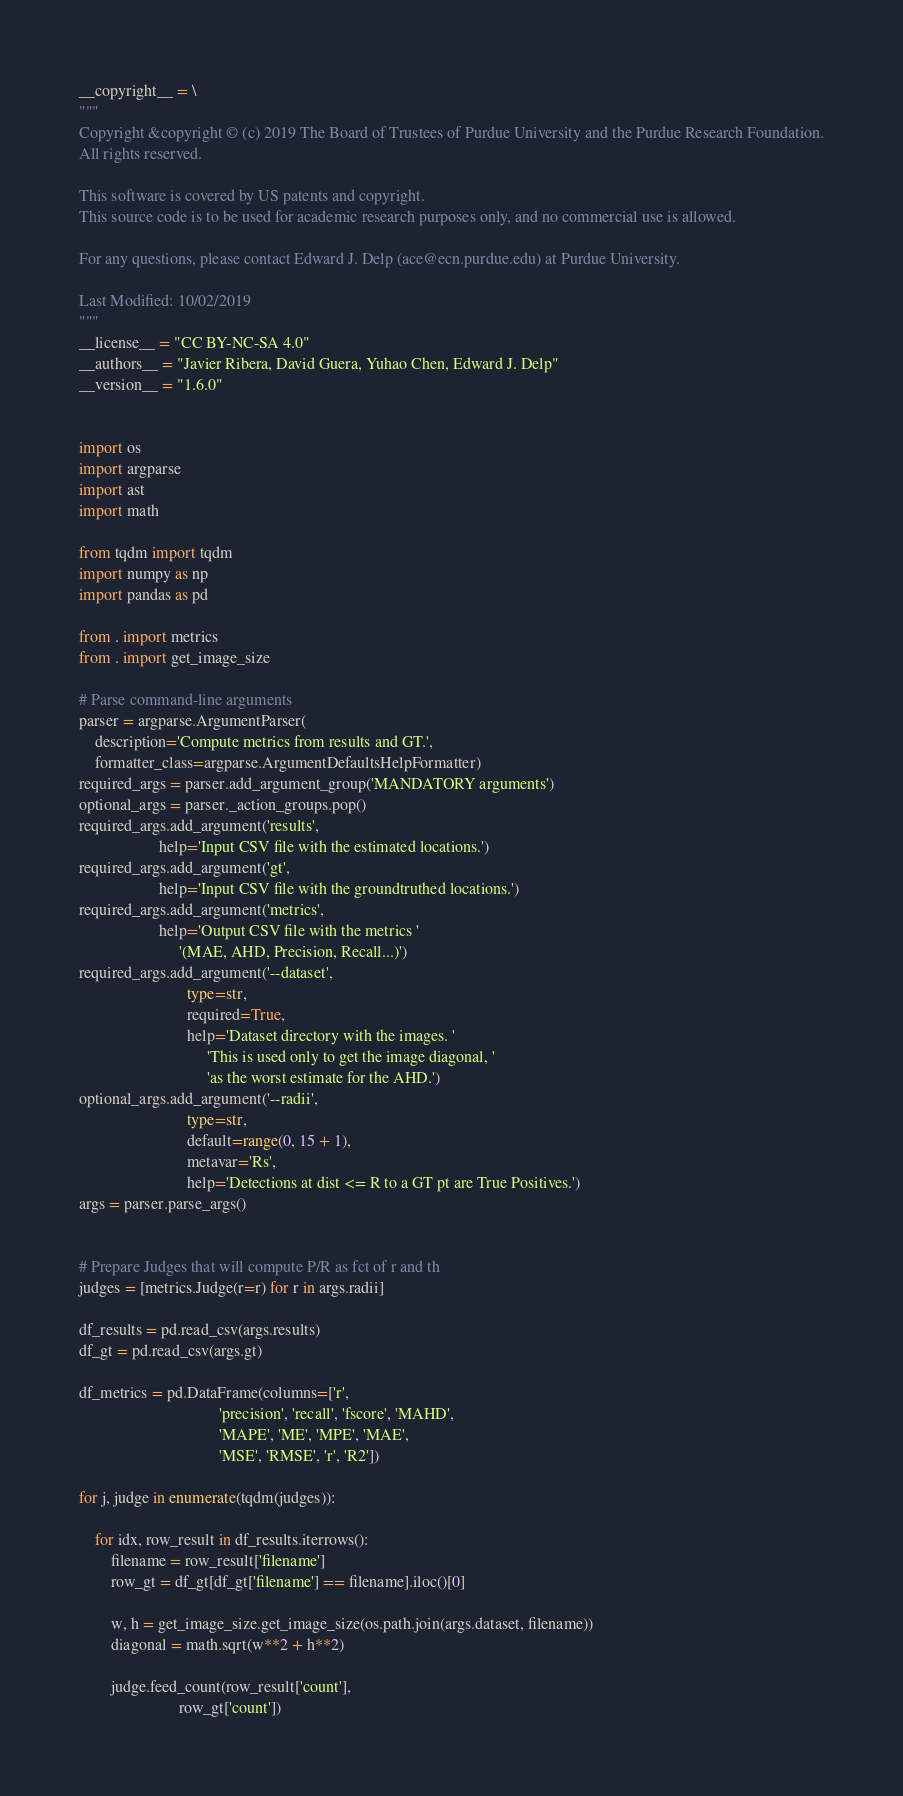Convert code to text. <code><loc_0><loc_0><loc_500><loc_500><_Python_>__copyright__ = \
"""
Copyright &copyright © (c) 2019 The Board of Trustees of Purdue University and the Purdue Research Foundation.
All rights reserved.

This software is covered by US patents and copyright.
This source code is to be used for academic research purposes only, and no commercial use is allowed.

For any questions, please contact Edward J. Delp (ace@ecn.purdue.edu) at Purdue University.

Last Modified: 10/02/2019 
"""
__license__ = "CC BY-NC-SA 4.0"
__authors__ = "Javier Ribera, David Guera, Yuhao Chen, Edward J. Delp"
__version__ = "1.6.0"


import os
import argparse
import ast
import math

from tqdm import tqdm
import numpy as np
import pandas as pd

from . import metrics
from . import get_image_size

# Parse command-line arguments
parser = argparse.ArgumentParser(
    description='Compute metrics from results and GT.',
    formatter_class=argparse.ArgumentDefaultsHelpFormatter)
required_args = parser.add_argument_group('MANDATORY arguments')
optional_args = parser._action_groups.pop()
required_args.add_argument('results',
                    help='Input CSV file with the estimated locations.')
required_args.add_argument('gt',
                    help='Input CSV file with the groundtruthed locations.')
required_args.add_argument('metrics',
                    help='Output CSV file with the metrics '
                         '(MAE, AHD, Precision, Recall...)')
required_args.add_argument('--dataset',
                           type=str,
                           required=True,
                           help='Dataset directory with the images. '
                                'This is used only to get the image diagonal, '
                                'as the worst estimate for the AHD.')
optional_args.add_argument('--radii',
                           type=str,
                           default=range(0, 15 + 1),
                           metavar='Rs',
                           help='Detections at dist <= R to a GT pt are True Positives.')
args = parser.parse_args()


# Prepare Judges that will compute P/R as fct of r and th
judges = [metrics.Judge(r=r) for r in args.radii]

df_results = pd.read_csv(args.results)
df_gt = pd.read_csv(args.gt)

df_metrics = pd.DataFrame(columns=['r',
                                   'precision', 'recall', 'fscore', 'MAHD',
                                   'MAPE', 'ME', 'MPE', 'MAE',
                                   'MSE', 'RMSE', 'r', 'R2'])

for j, judge in enumerate(tqdm(judges)):

    for idx, row_result in df_results.iterrows():
        filename = row_result['filename']
        row_gt = df_gt[df_gt['filename'] == filename].iloc()[0]

        w, h = get_image_size.get_image_size(os.path.join(args.dataset, filename))
        diagonal = math.sqrt(w**2 + h**2)

        judge.feed_count(row_result['count'],
                         row_gt['count'])</code> 